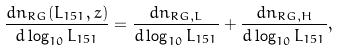Convert formula to latex. <formula><loc_0><loc_0><loc_500><loc_500>\frac { d n _ { R G } ( L _ { 1 5 1 } , z ) } { d \log _ { 1 0 } L _ { 1 5 1 } } = \frac { d n _ { R G , L } } { d \log _ { 1 0 } L _ { 1 5 1 } } + \frac { d n _ { R G , H } } { d \log _ { 1 0 } L _ { 1 5 1 } } ,</formula> 